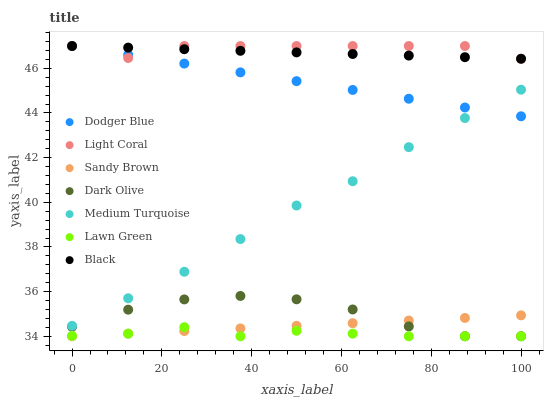Does Lawn Green have the minimum area under the curve?
Answer yes or no. Yes. Does Light Coral have the maximum area under the curve?
Answer yes or no. Yes. Does Dark Olive have the minimum area under the curve?
Answer yes or no. No. Does Dark Olive have the maximum area under the curve?
Answer yes or no. No. Is Dodger Blue the smoothest?
Answer yes or no. Yes. Is Dark Olive the roughest?
Answer yes or no. Yes. Is Light Coral the smoothest?
Answer yes or no. No. Is Light Coral the roughest?
Answer yes or no. No. Does Lawn Green have the lowest value?
Answer yes or no. Yes. Does Light Coral have the lowest value?
Answer yes or no. No. Does Black have the highest value?
Answer yes or no. Yes. Does Dark Olive have the highest value?
Answer yes or no. No. Is Lawn Green less than Dodger Blue?
Answer yes or no. Yes. Is Black greater than Lawn Green?
Answer yes or no. Yes. Does Dodger Blue intersect Light Coral?
Answer yes or no. Yes. Is Dodger Blue less than Light Coral?
Answer yes or no. No. Is Dodger Blue greater than Light Coral?
Answer yes or no. No. Does Lawn Green intersect Dodger Blue?
Answer yes or no. No. 